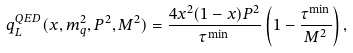Convert formula to latex. <formula><loc_0><loc_0><loc_500><loc_500>q ^ { Q E D } _ { L } ( x , m _ { q } ^ { 2 } , P ^ { 2 } , M ^ { 2 } ) = \frac { 4 x ^ { 2 } ( 1 - x ) P ^ { 2 } } { \tau ^ { \min } } \left ( 1 - \frac { \tau ^ { \min } } { M ^ { 2 } } \right ) ,</formula> 